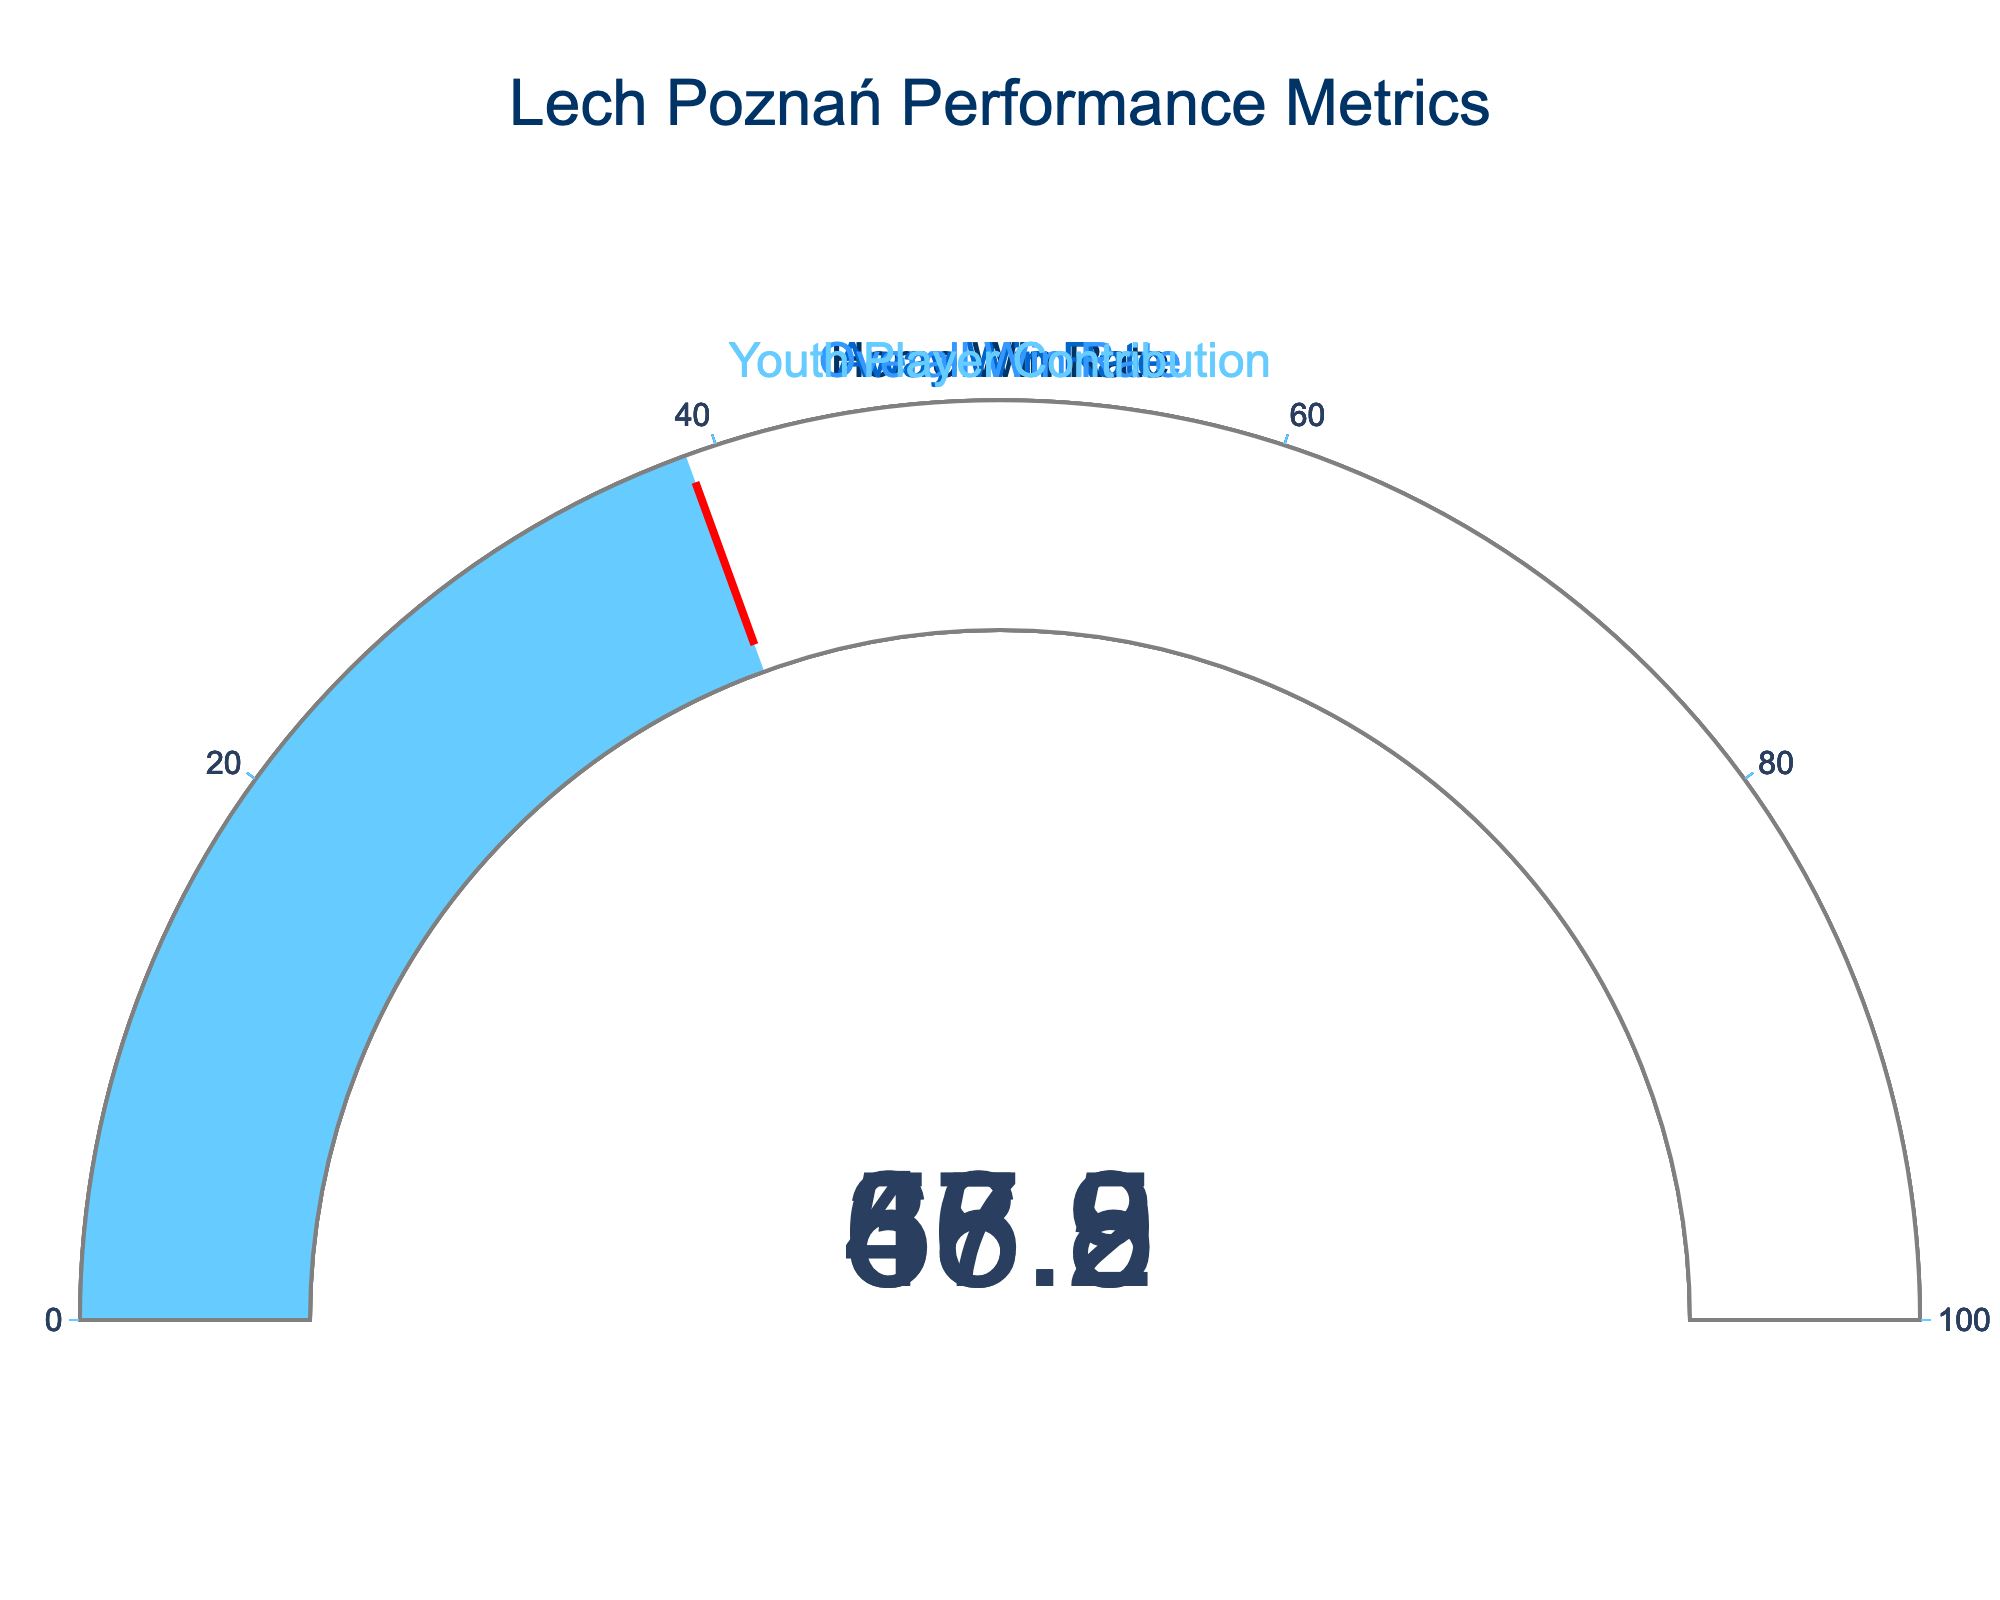What's the overall win rate of Lech Poznań in the current Ekstraklasa season? The "Overall Win Rate" gauge shows the value of 56.5
Answer: 56.5 Which gauge represents the highest win rate? Compare the values shown in each gauge: Home Win Rate (65.2), Away Win Rate (47.8), Overall Win Rate (56.5), Youth Player Contribution (38.9). The highest value is 65.2 for Home Win Rate
Answer: Home Win Rate What's the difference between Home Win Rate and Away Win Rate? Subtract the Away Win Rate value from the Home Win Rate value: 65.2 - 47.8
Answer: 17.4 How much does the Youth Player Contribution rate add to the Home Win Rate? Add the values of Youth Player Contribution and Home Win Rate: 38.9 + 65.2
Answer: 104.1 Is the Overall Win Rate higher or lower than Youth Player Contribution? Compare Overall Win Rate (56.5) with Youth Player Contribution (38.9). 56.5 is higher than 38.9
Answer: Higher What percentage of Lech Poznań's performance is contributed by youth players? The "Youth Player Contribution" gauge shows the value of 38.9
Answer: 38.9 How much less is the Youth Player Contribution rate compared to the Home Win Rate? Subtract Youth Player Contribution from Home Win Rate: 65.2 - 38.9
Answer: 26.3 What is the average win rate combining Home and Away rates? Add Home Win Rate and Away Win Rate, then divide by 2: (65.2 + 47.8) / 2
Answer: 56.5 